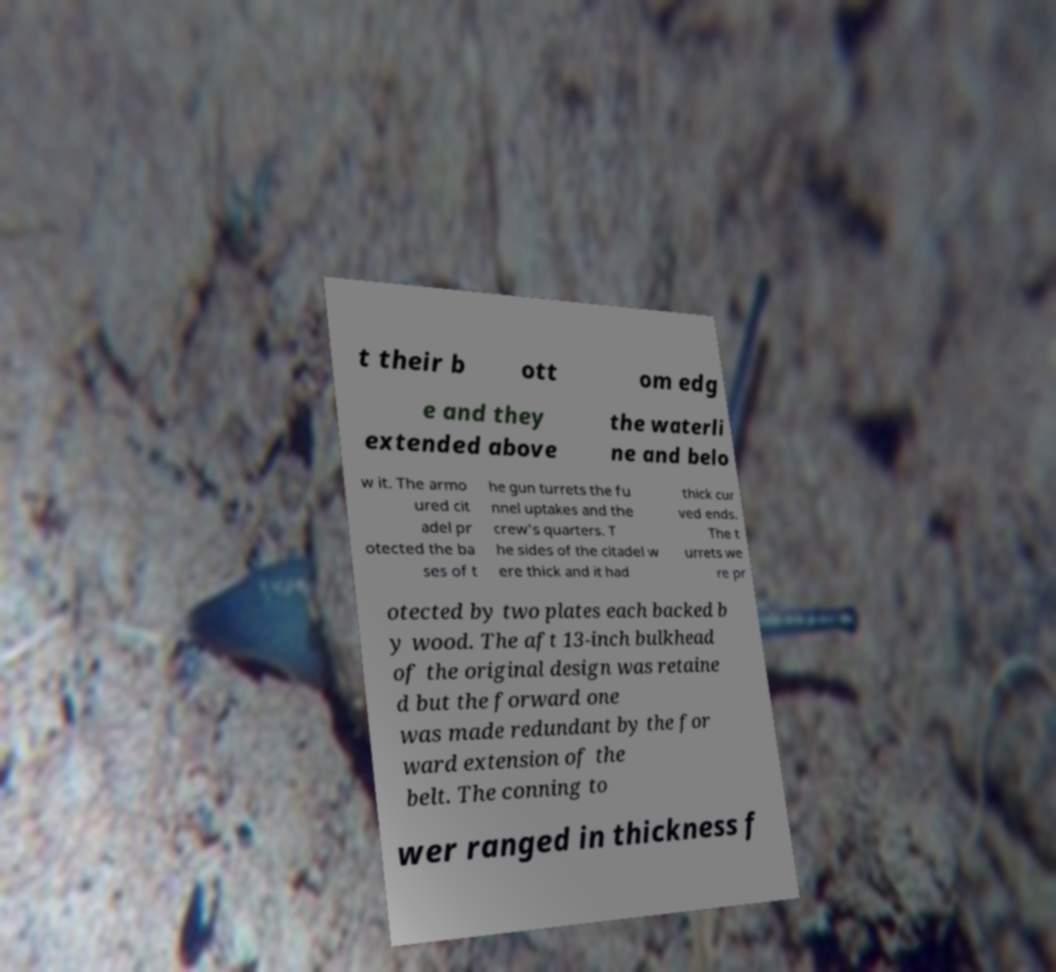What messages or text are displayed in this image? I need them in a readable, typed format. t their b ott om edg e and they extended above the waterli ne and belo w it. The armo ured cit adel pr otected the ba ses of t he gun turrets the fu nnel uptakes and the crew's quarters. T he sides of the citadel w ere thick and it had thick cur ved ends. The t urrets we re pr otected by two plates each backed b y wood. The aft 13-inch bulkhead of the original design was retaine d but the forward one was made redundant by the for ward extension of the belt. The conning to wer ranged in thickness f 